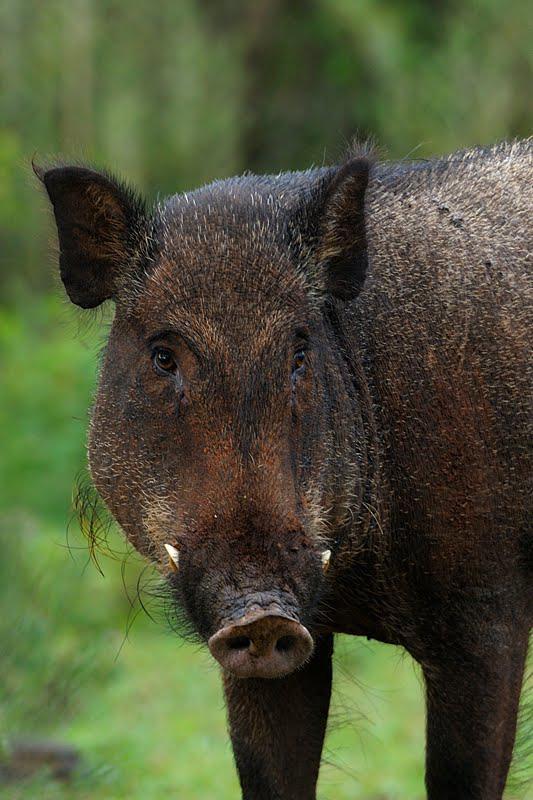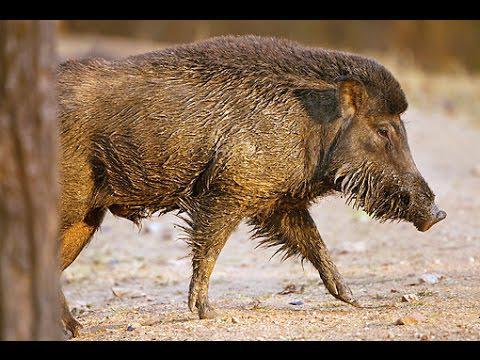The first image is the image on the left, the second image is the image on the right. Assess this claim about the two images: "An image shows one wild pig with the carcass of a spotted hooved animal.". Correct or not? Answer yes or no. No. The first image is the image on the left, the second image is the image on the right. Considering the images on both sides, is "There are two wild pigs out in the wild." valid? Answer yes or no. Yes. 